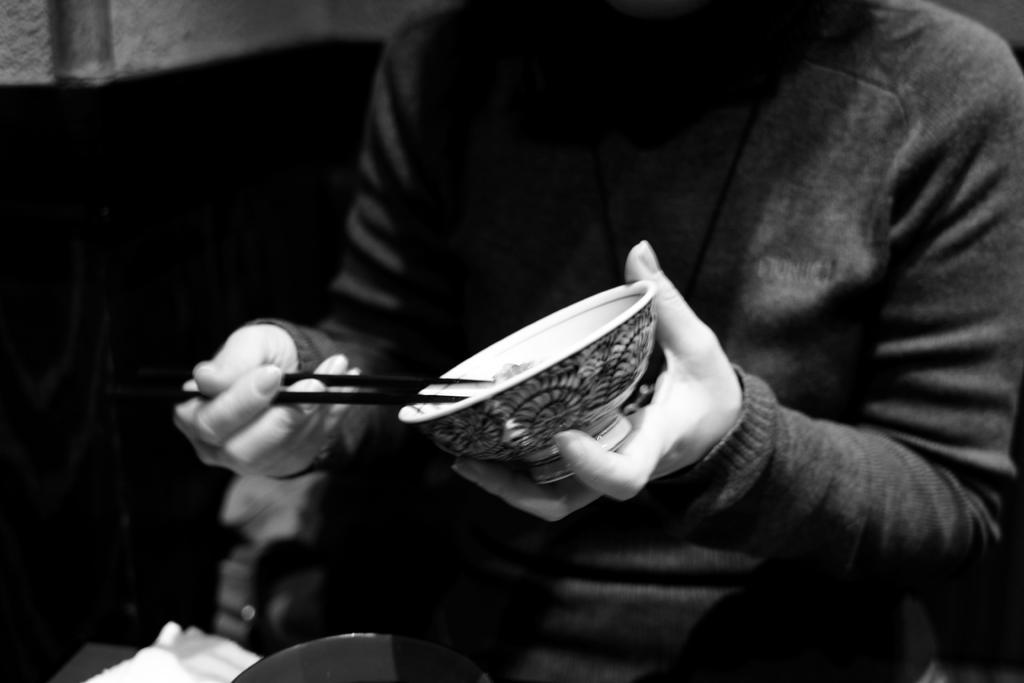Please provide a concise description of this image. In this picture there is a person holding a bowl in his hand with two chopsticks, sitting in a chair. 